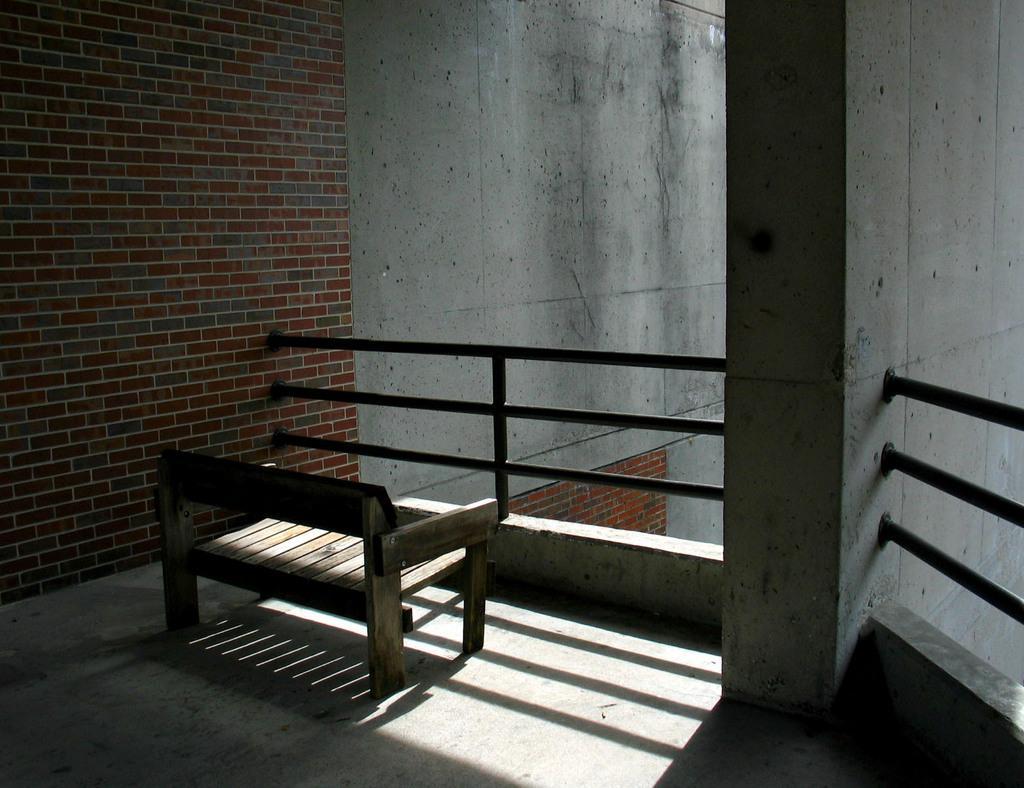Describe this image in one or two sentences. In this image we can see there are walls and there is the railing. There is the bench on the floor. 